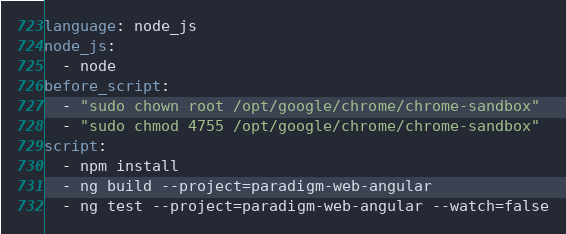Convert code to text. <code><loc_0><loc_0><loc_500><loc_500><_YAML_>language: node_js
node_js:
  - node
before_script:
  - "sudo chown root /opt/google/chrome/chrome-sandbox"
  - "sudo chmod 4755 /opt/google/chrome/chrome-sandbox"
script:
  - npm install
  - ng build --project=paradigm-web-angular
  - ng test --project=paradigm-web-angular --watch=false
</code> 